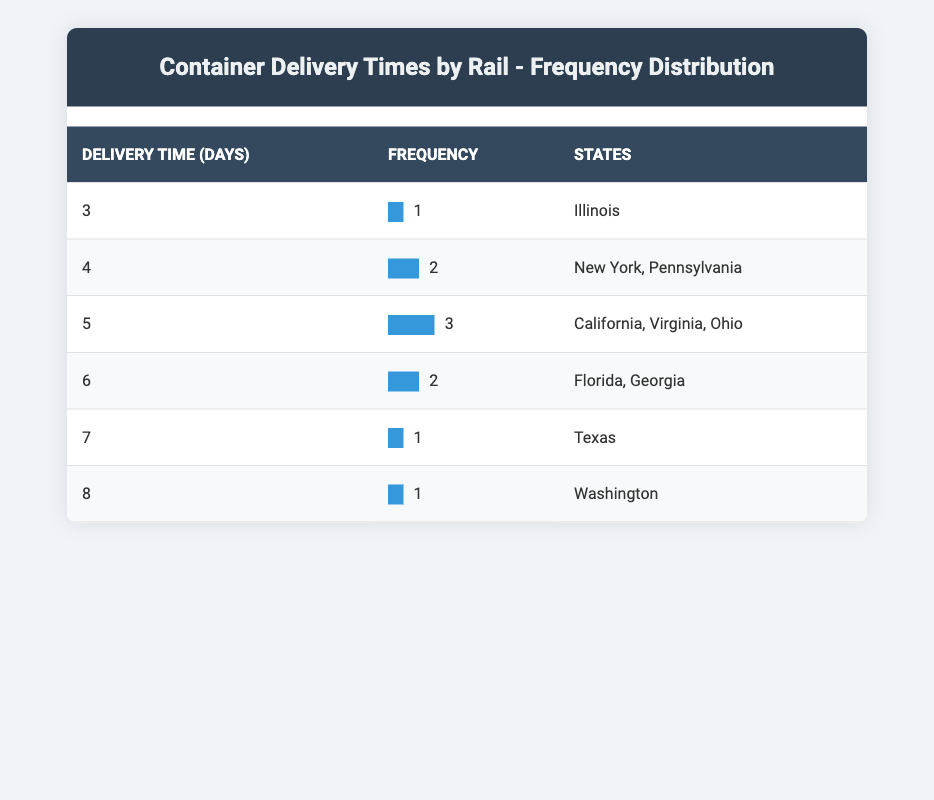What is the delivery time for Illinois? According to the table, Illinois has a delivery time of 3 days.
Answer: 3 How many states have a delivery time of 5 days? The table indicates that there are 3 states with a delivery time of 5 days: California, Virginia, and Ohio.
Answer: 3 Which state has the longest delivery time? By examining the delivery times, Washington has the longest delivery time at 8 days.
Answer: Washington Is New York one of the states that have a delivery time of 4 days? The table shows that New York is indeed listed with a delivery time of 4 days.
Answer: Yes What is the average delivery time across all states listed in the table? To find the average, we sum all the delivery times: (5 + 7 + 4 + 6 + 3 + 5 + 6 + 8 + 4 + 5) = 63. Then, dividing by the number of states (10), we get 63/10 = 6.3.
Answer: 6.3 How many states have a delivery time greater than 5 days? From the table, only Washington has a delivery time greater than 5 days (8 days). Thus, there is only one state.
Answer: 1 If two more states were added with a delivery time of 6 days, what would be the new average delivery time? Initially, the sum of the delivery times is 63 for 10 states. Adding two more states with 6 days each, the new sum becomes 63 + 12 = 75. The number of states now increases to 12, so the new average is 75/12 = 6.25.
Answer: 6.25 Which states have the same delivery time as Florida? Florida has a delivery time of 6 days. The only other state with the same delivery time is Georgia.
Answer: Georgia Is there any state that has a delivery time of exactly 2 days? Reviewing the table, there are no states listed with a delivery time of 2 days.
Answer: No 